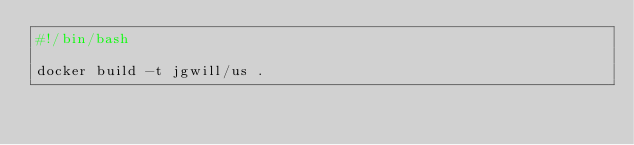Convert code to text. <code><loc_0><loc_0><loc_500><loc_500><_Bash_>#!/bin/bash

docker build -t jgwill/us .

</code> 